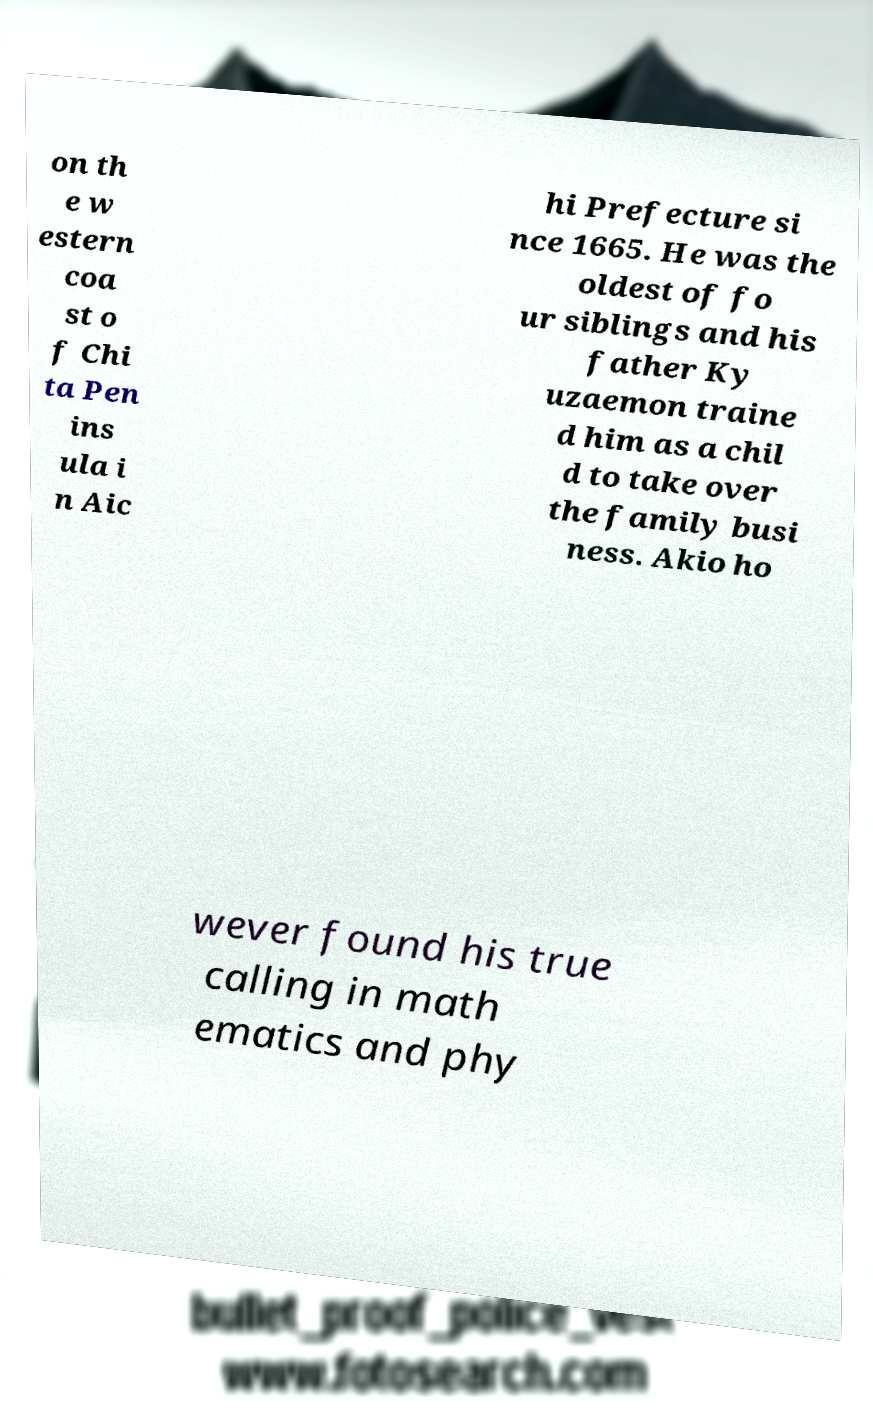Could you assist in decoding the text presented in this image and type it out clearly? on th e w estern coa st o f Chi ta Pen ins ula i n Aic hi Prefecture si nce 1665. He was the oldest of fo ur siblings and his father Ky uzaemon traine d him as a chil d to take over the family busi ness. Akio ho wever found his true calling in math ematics and phy 